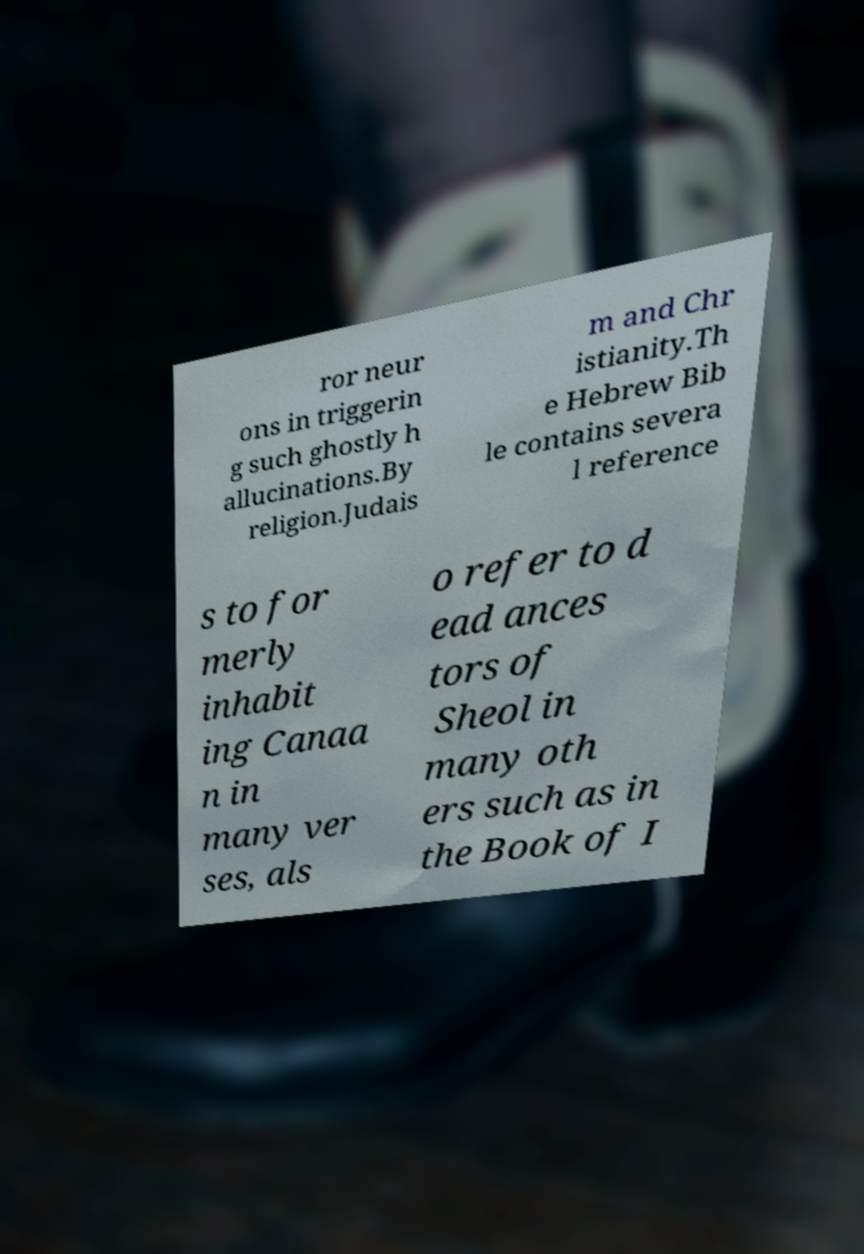Please identify and transcribe the text found in this image. ror neur ons in triggerin g such ghostly h allucinations.By religion.Judais m and Chr istianity.Th e Hebrew Bib le contains severa l reference s to for merly inhabit ing Canaa n in many ver ses, als o refer to d ead ances tors of Sheol in many oth ers such as in the Book of I 